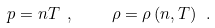Convert formula to latex. <formula><loc_0><loc_0><loc_500><loc_500>p = n T \ , \quad \ \rho = \rho \left ( n , T \right ) \ .</formula> 